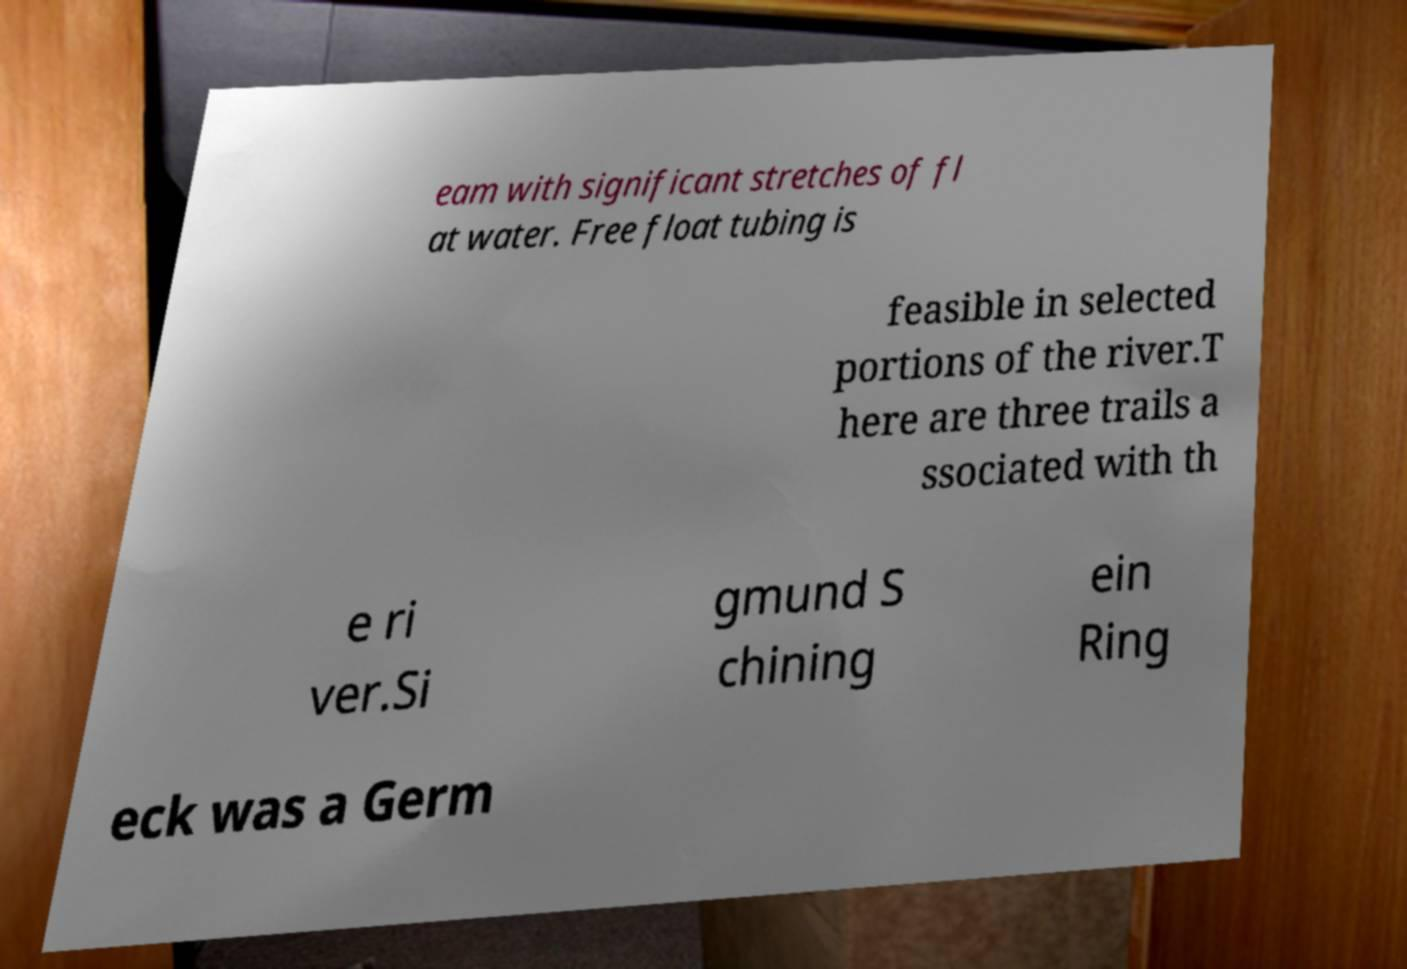Please identify and transcribe the text found in this image. eam with significant stretches of fl at water. Free float tubing is feasible in selected portions of the river.T here are three trails a ssociated with th e ri ver.Si gmund S chining ein Ring eck was a Germ 